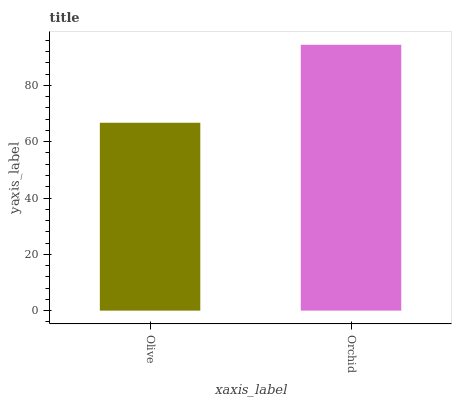Is Olive the minimum?
Answer yes or no. Yes. Is Orchid the maximum?
Answer yes or no. Yes. Is Orchid the minimum?
Answer yes or no. No. Is Orchid greater than Olive?
Answer yes or no. Yes. Is Olive less than Orchid?
Answer yes or no. Yes. Is Olive greater than Orchid?
Answer yes or no. No. Is Orchid less than Olive?
Answer yes or no. No. Is Orchid the high median?
Answer yes or no. Yes. Is Olive the low median?
Answer yes or no. Yes. Is Olive the high median?
Answer yes or no. No. Is Orchid the low median?
Answer yes or no. No. 